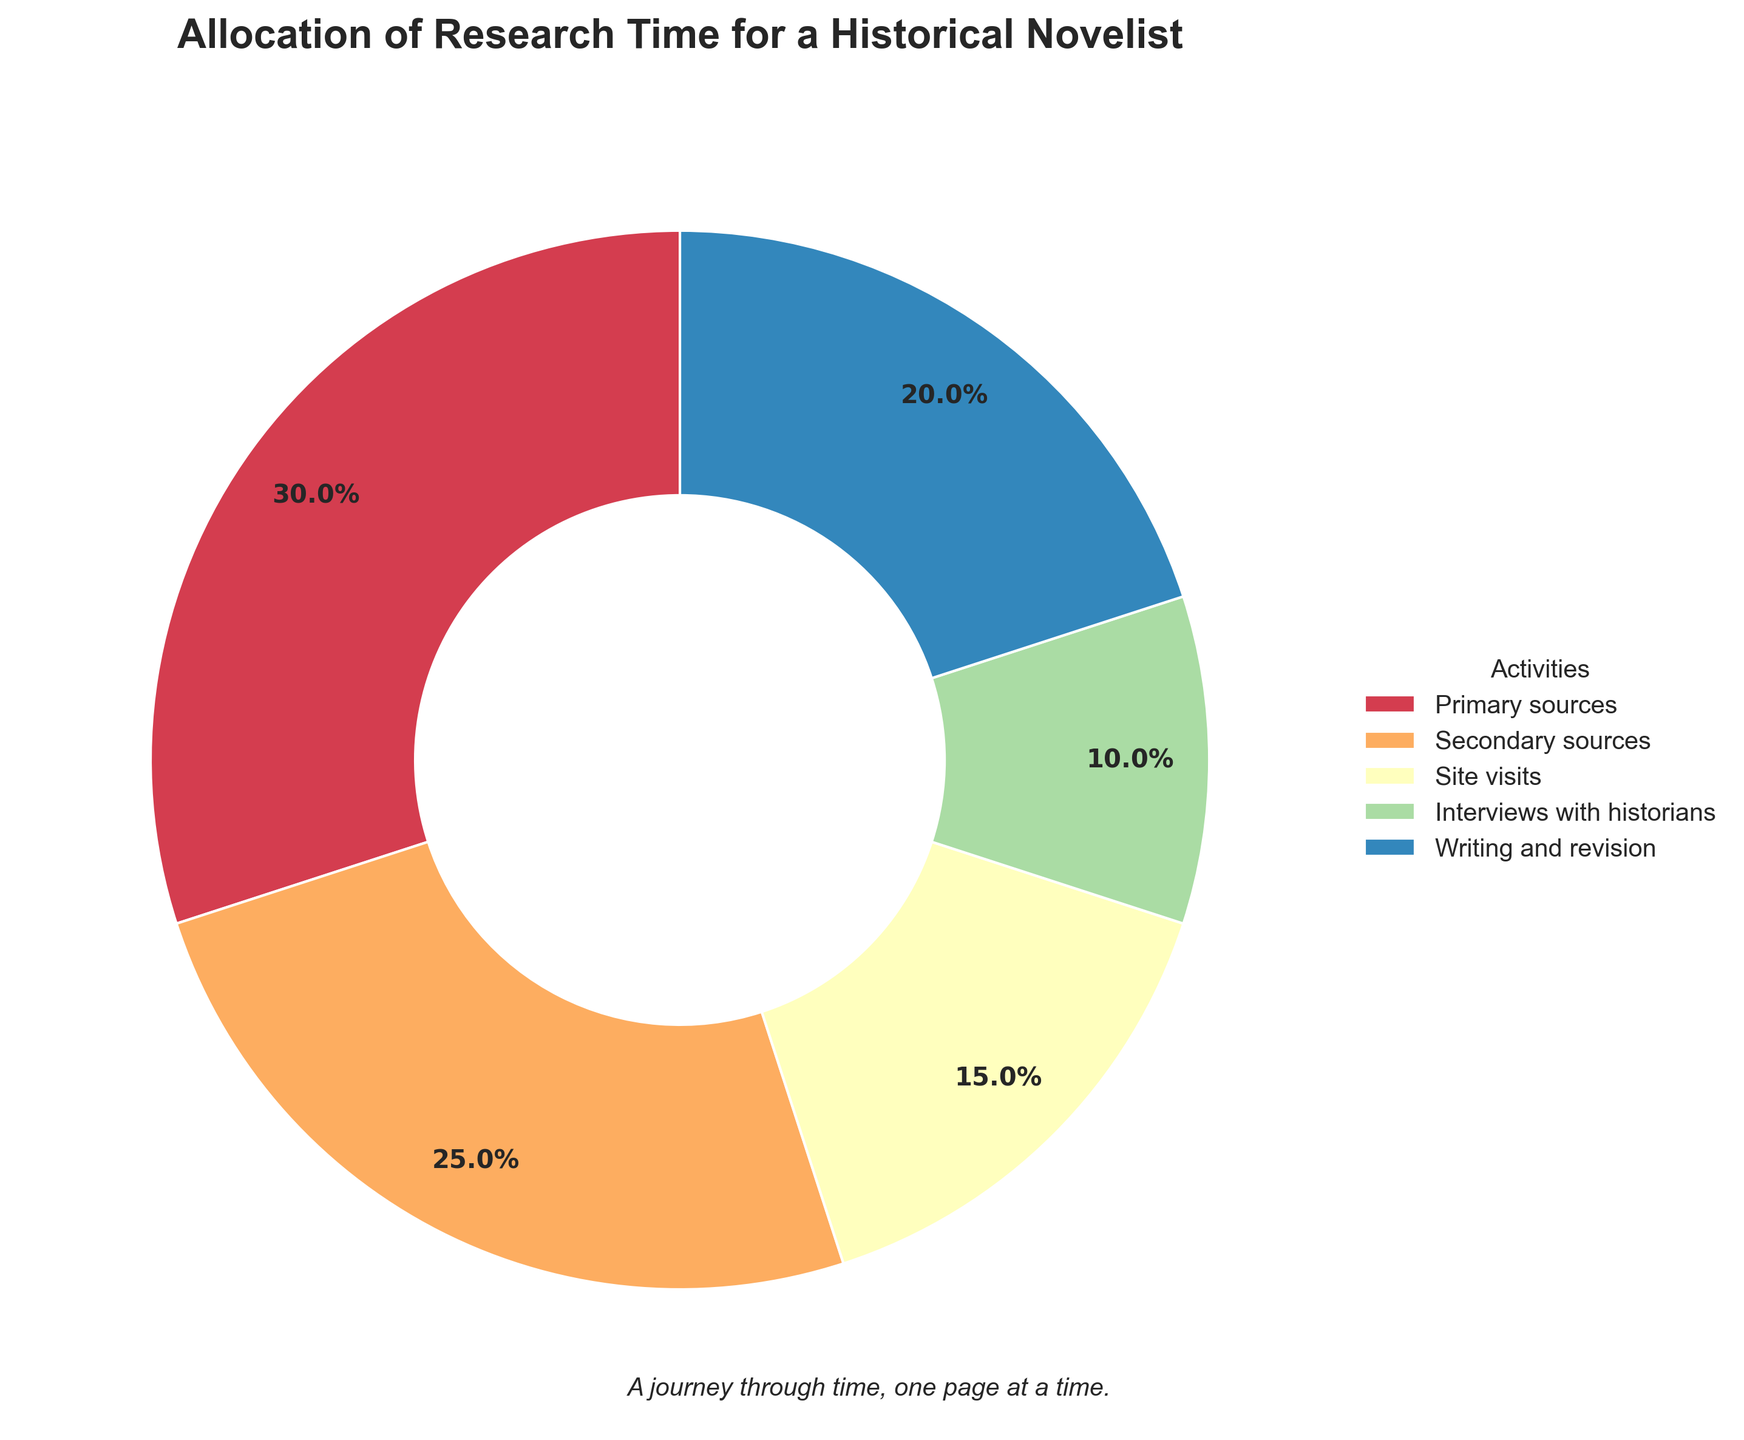Which activity takes the largest share of research time? By looking at the pie chart, the section with the largest percentage represents the activity taking the most time. The “Primary sources” section occupies the largest segment with 30%.
Answer: Primary sources How much more time is allocated to Primary sources compared to Site visits? From the chart, Primary sources take 30% of the time, and Site visits take 15%. The difference is 30% - 15% = 15%.
Answer: 15% What percentage of research time is spent on Writing and revision? From the chart, the Writing and revision section is indicated to take 20% of the whole research time.
Answer: 20% How do the combined percentages of Interviews with historians and Secondary sources compare to the time spent on Primary sources? Interviews with historians (10%) and Secondary sources (25%) together take 10% + 25% = 35%. Primary sources take 30%, so 35% is 5% more than 30%.
Answer: 5% more Is the time spent on Site visits greater than the time spent on Interviews with historians? By observing the pie chart, Site visits account for 15%, and Interviews with historians account for 10%. Since 15% is greater than 10%, the time spent on Site visits is indeed more.
Answer: Yes Which activities combined take up half (50%) of the research time? Adding up the percentages from the pie chart: Primary sources (30%) + Writing and revision (20%) = 50%. The combination of these two activities takes up half of the research time.
Answer: Primary sources and Writing and revision What is the collective percentage of time spent on activities other than Primary sources? Aside from Primary sources (30%), the other activities are Secondary sources (25%) + Site visits (15%) + Interviews with historians (10%) + Writing and revision (20%) = 70%.
Answer: 70% How does the time allocated to Secondary sources compare to Writing and revision? From the chart, Secondary sources take up 25%, while Writing and revision account for 20%. Since 25% is more than 20%, more time is allocated to Secondary sources than Writing and revision.
Answer: More time is allocated to Secondary sources By how much does the allocation for Writing and revision exceed the allocation for Interviews with historians? Writing and revision take 20% of the time, whereas Interviews with historians take 10%. The excess is 20% - 10% = 10%.
Answer: 10% Which section in the pie chart is represented with the most contrasting color? Visually, the pie chart uses distinct shades, with the largest contrasting section to the rest generally standing out. In this case, Primary sources section with 30% takes a central and contrasting visual due to its larger area and distinct color from the rest.
Answer: Primary sources 